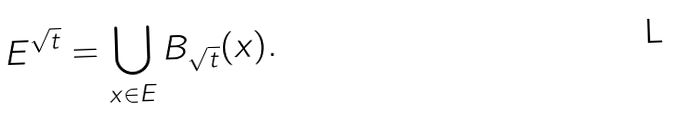<formula> <loc_0><loc_0><loc_500><loc_500>E ^ { \sqrt { t } } = \bigcup _ { x \in E } B _ { \sqrt { t } } ( x ) .</formula> 